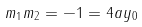Convert formula to latex. <formula><loc_0><loc_0><loc_500><loc_500>m _ { 1 } m _ { 2 } = - 1 = 4 a y _ { 0 }</formula> 